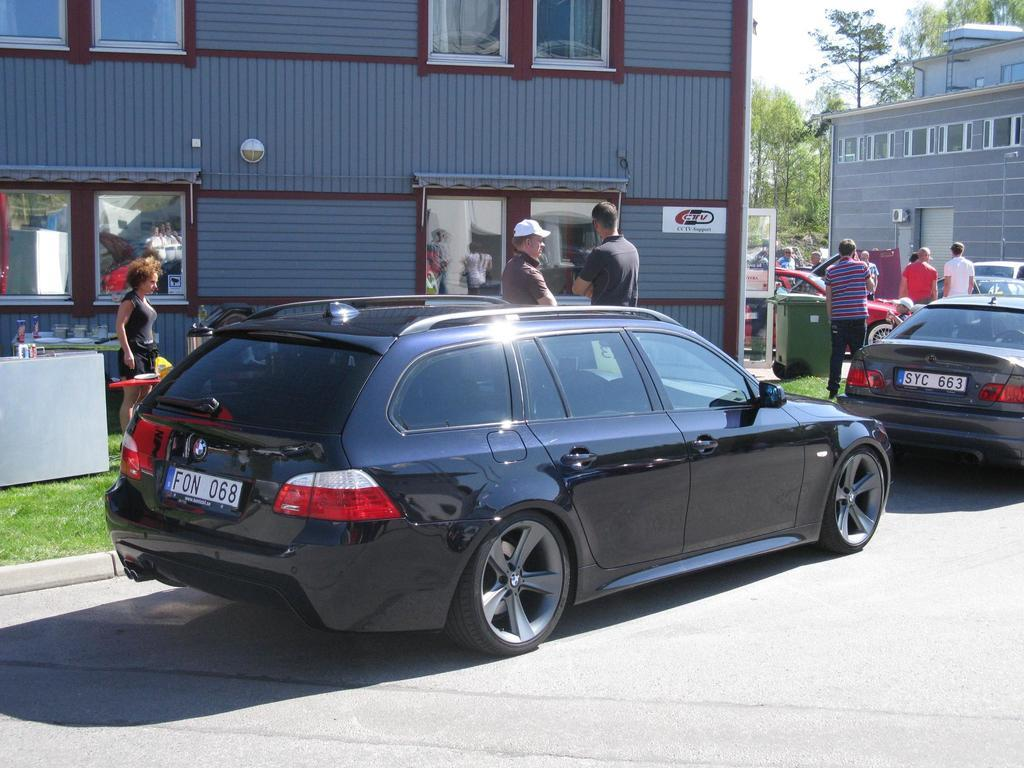<image>
Render a clear and concise summary of the photo. Two men engaging in a conversation at a CTV Support shop infront of a BMW with license plate F0N 068 